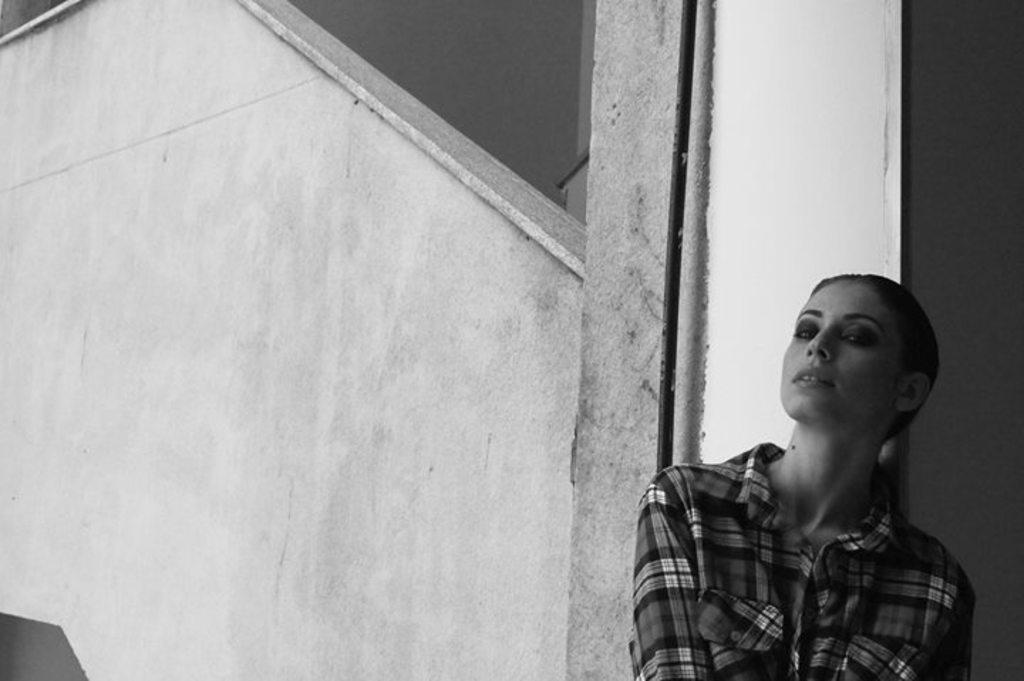Who is present in the image? There is a woman in the image. What can be seen in the background of the image? There is a wall in the background of the image. How many dogs are visible in the image? There are no dogs present in the image. What direction is the woman pointing in the image? The image does not show the woman pointing in any direction. 